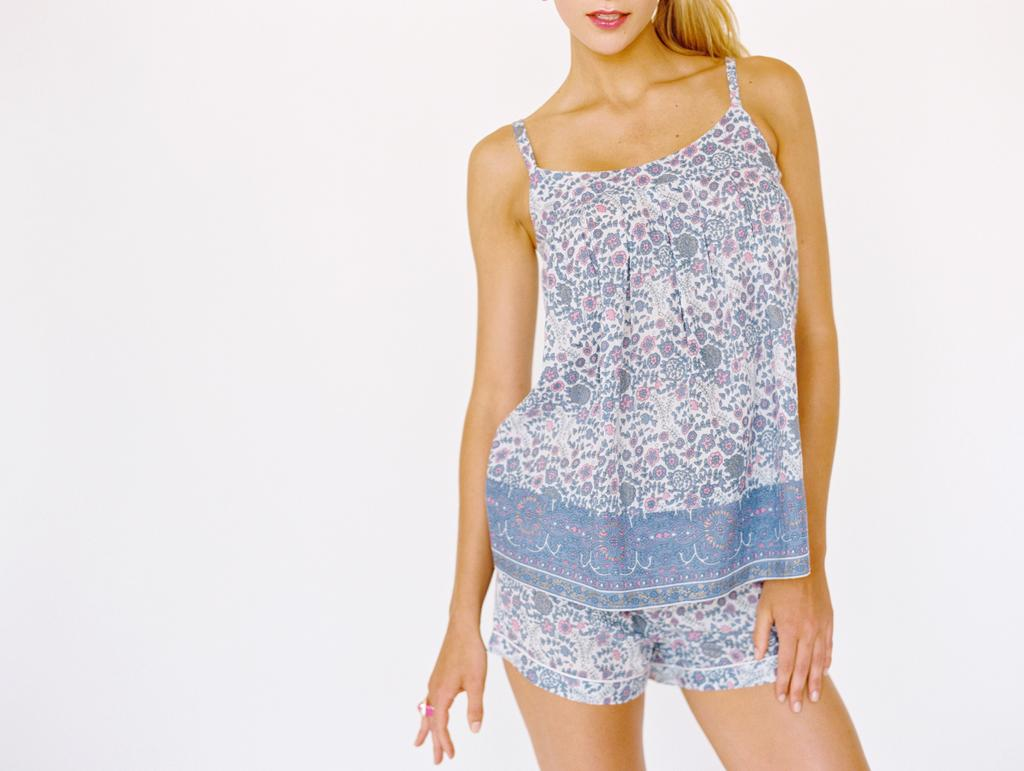Who is the main subject in the picture? There is a woman in the picture. What is the woman doing in the image? The woman is standing in front. What is the woman wearing in the image? The woman is wearing a white and blue color dress. What is the color of the background in the image? The background of the image is white. How long does it take for the cat to walk across the image? There is no cat present in the image, so it is not possible to determine how long it would take for a cat to walk across the image. 